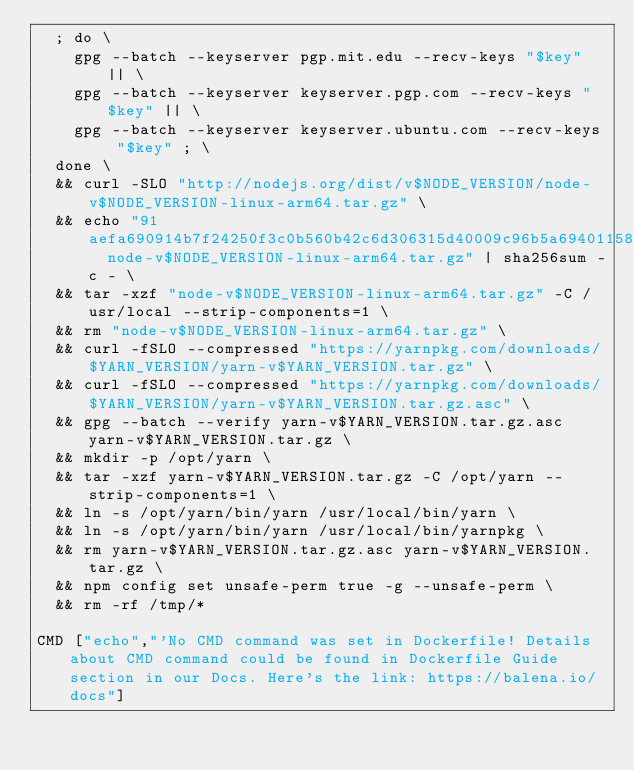Convert code to text. <code><loc_0><loc_0><loc_500><loc_500><_Dockerfile_>	; do \
		gpg --batch --keyserver pgp.mit.edu --recv-keys "$key" || \
		gpg --batch --keyserver keyserver.pgp.com --recv-keys "$key" || \
		gpg --batch --keyserver keyserver.ubuntu.com --recv-keys "$key" ; \
	done \
	&& curl -SLO "http://nodejs.org/dist/v$NODE_VERSION/node-v$NODE_VERSION-linux-arm64.tar.gz" \
	&& echo "91aefa690914b7f24250f3c0b560b42c6d306315d40009c96b5a6940115895fe  node-v$NODE_VERSION-linux-arm64.tar.gz" | sha256sum -c - \
	&& tar -xzf "node-v$NODE_VERSION-linux-arm64.tar.gz" -C /usr/local --strip-components=1 \
	&& rm "node-v$NODE_VERSION-linux-arm64.tar.gz" \
	&& curl -fSLO --compressed "https://yarnpkg.com/downloads/$YARN_VERSION/yarn-v$YARN_VERSION.tar.gz" \
	&& curl -fSLO --compressed "https://yarnpkg.com/downloads/$YARN_VERSION/yarn-v$YARN_VERSION.tar.gz.asc" \
	&& gpg --batch --verify yarn-v$YARN_VERSION.tar.gz.asc yarn-v$YARN_VERSION.tar.gz \
	&& mkdir -p /opt/yarn \
	&& tar -xzf yarn-v$YARN_VERSION.tar.gz -C /opt/yarn --strip-components=1 \
	&& ln -s /opt/yarn/bin/yarn /usr/local/bin/yarn \
	&& ln -s /opt/yarn/bin/yarn /usr/local/bin/yarnpkg \
	&& rm yarn-v$YARN_VERSION.tar.gz.asc yarn-v$YARN_VERSION.tar.gz \
	&& npm config set unsafe-perm true -g --unsafe-perm \
	&& rm -rf /tmp/*

CMD ["echo","'No CMD command was set in Dockerfile! Details about CMD command could be found in Dockerfile Guide section in our Docs. Here's the link: https://balena.io/docs"]
</code> 